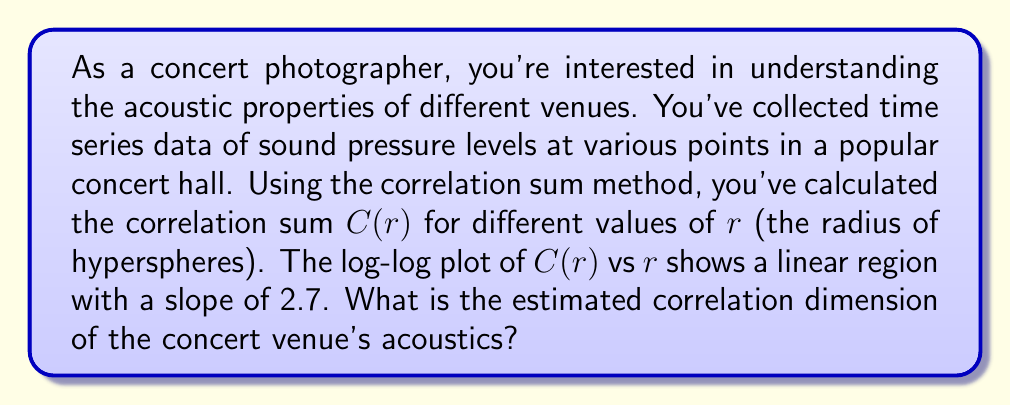Show me your answer to this math problem. To estimate the correlation dimension of the concert venue's acoustics, we'll follow these steps:

1. Recall that the correlation dimension $D_2$ is defined as:

   $$D_2 = \lim_{r \to 0} \frac{\log C(r)}{\log r}$$

   where $C(r)$ is the correlation sum and $r$ is the radius of hyperspheres.

2. In practice, we estimate $D_2$ by plotting $\log C(r)$ against $\log r$ and measuring the slope of the linear region.

3. The slope of the log-log plot is directly related to the correlation dimension. In fact, the slope is the correlation dimension.

4. In this case, we're given that the slope of the linear region in the log-log plot is 2.7.

5. Therefore, the estimated correlation dimension $D_2$ is equal to this slope value.

This result suggests that the acoustic dynamics in the concert venue have a fractional dimension, indicating a complex, potentially chaotic system. This information can be valuable for understanding how sound behaves in the space, which could inform your photography techniques for capturing the essence of live performances.
Answer: $D_2 = 2.7$ 